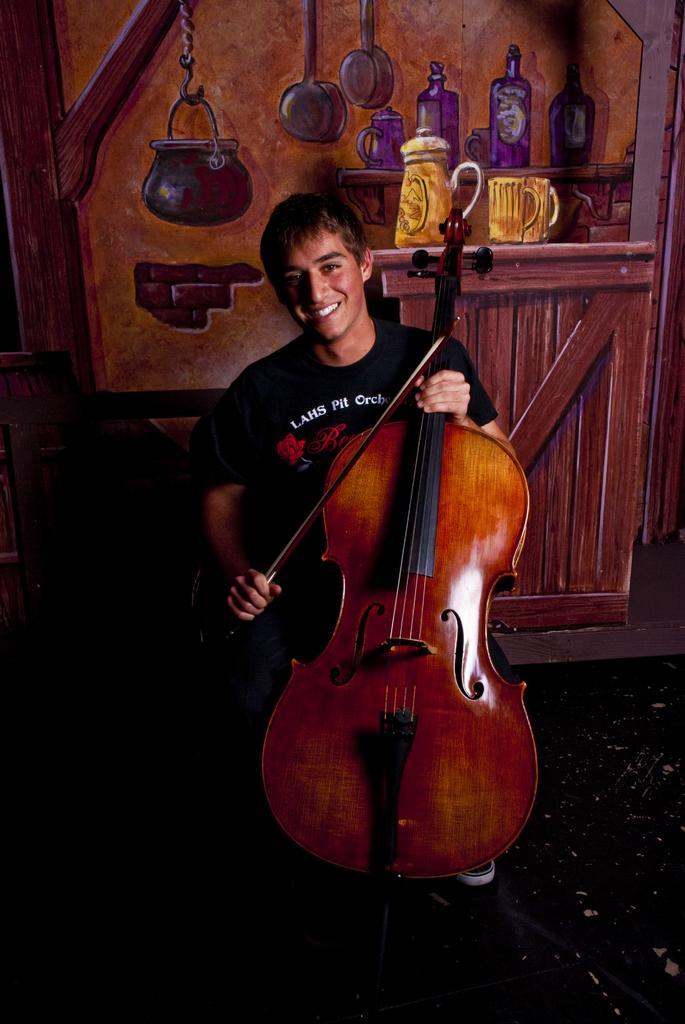In one or two sentences, can you explain what this image depicts? In the center of the image we can see a person holding a violin. In the background there is a wall and we can see a painting on the wall. On the left we can see a chair. 